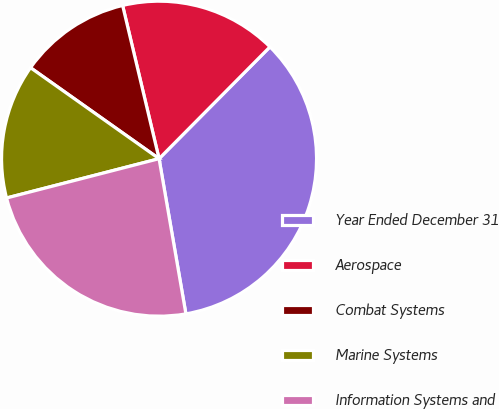<chart> <loc_0><loc_0><loc_500><loc_500><pie_chart><fcel>Year Ended December 31<fcel>Aerospace<fcel>Combat Systems<fcel>Marine Systems<fcel>Information Systems and<nl><fcel>34.84%<fcel>16.15%<fcel>11.48%<fcel>13.82%<fcel>23.71%<nl></chart> 